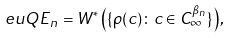<formula> <loc_0><loc_0><loc_500><loc_500>\ e u { Q E } _ { n } = W ^ { * } \left ( \{ \rho ( c ) \colon c \in C _ { \infty } ^ { \beta _ { n } } \} \right ) ,</formula> 